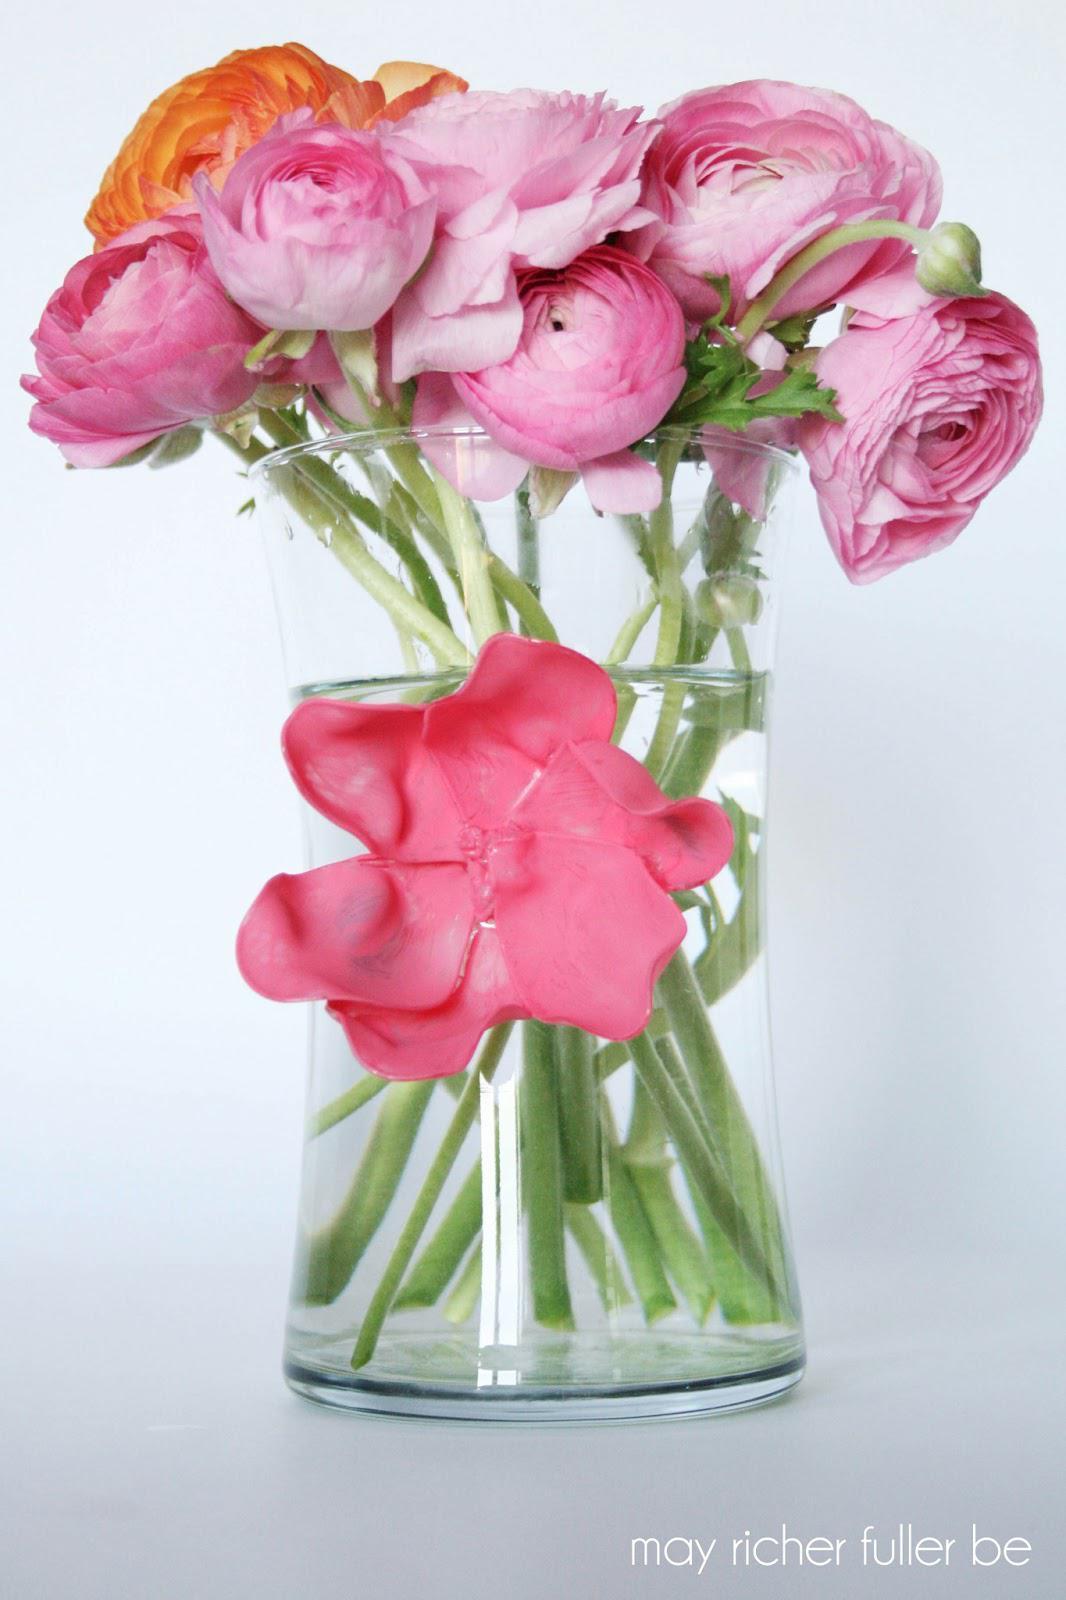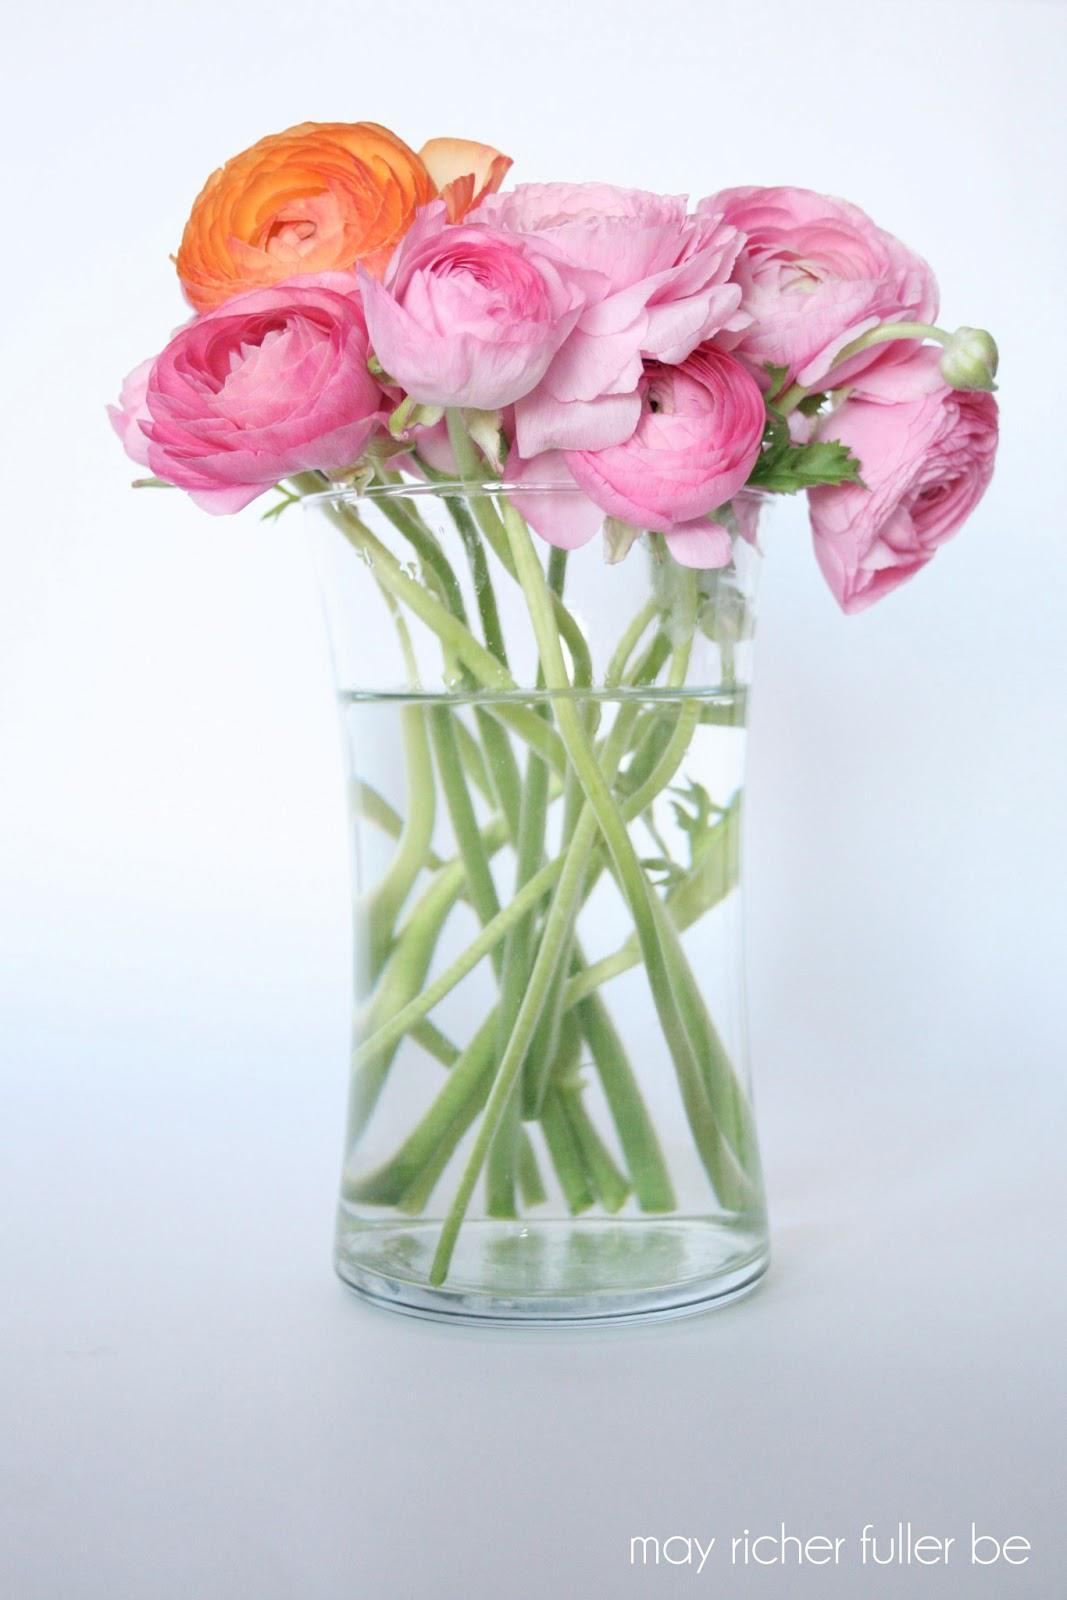The first image is the image on the left, the second image is the image on the right. Evaluate the accuracy of this statement regarding the images: "One of the images shows a vase of flowers with one single flower attached to the outside of the vase.". Is it true? Answer yes or no. Yes. The first image is the image on the left, the second image is the image on the right. Considering the images on both sides, is "The left image features a clear vase containing several pink roses and one orange one, and the vase has a solid-colored flower on its front." valid? Answer yes or no. Yes. 